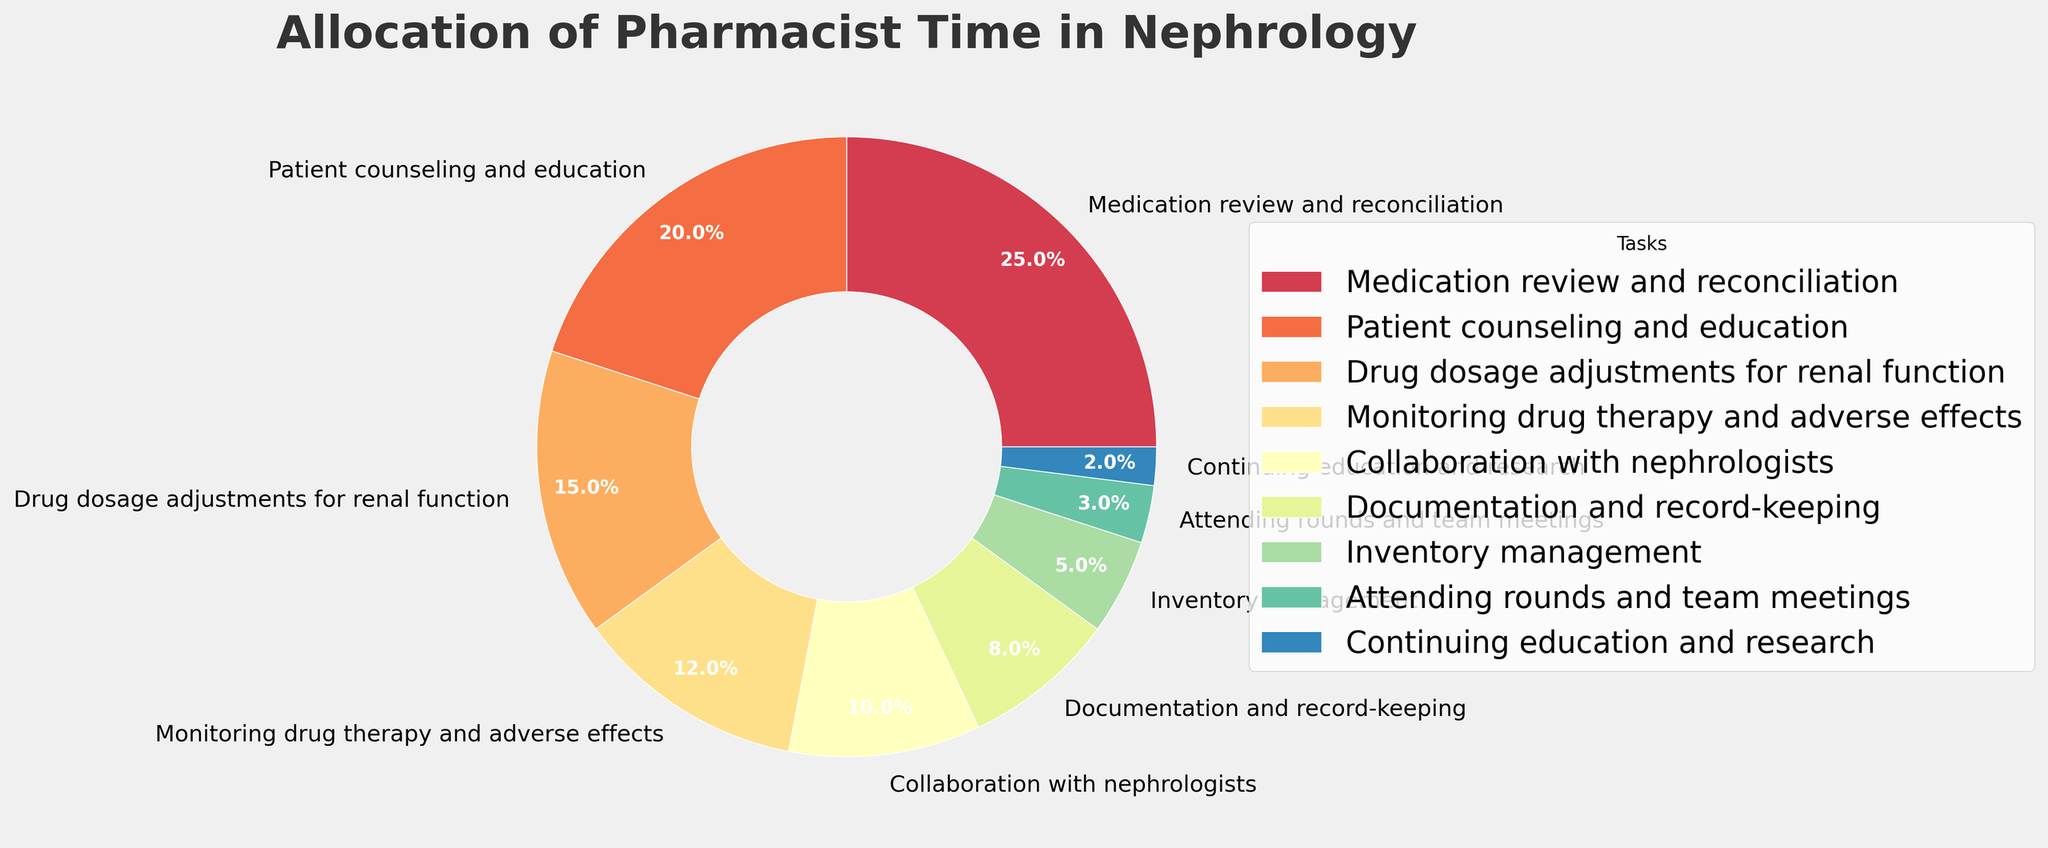What percentage of time is spent on Medication review and reconciliation? The pie chart will have a segment labeled 'Medication review and reconciliation' with its corresponding percentage.
Answer: 25% Which task takes up the least amount of time? Locate the smallest segment in the pie chart and check the label to identify the task.
Answer: Continuing education and research How much more time is allocated to Patient counseling and education compared to Inventory management? Identify the percentages for both 'Patient counseling and education' and 'Inventory management', then subtract the smaller percentage from the larger one: 20% - 5%.
Answer: 15% What is the combined percentage of time spent on Monitoring drug therapy and adverse effects and Documentation and record-keeping? Find the segments labeled 'Monitoring drug therapy and adverse effects' and 'Documentation and record-keeping', then add their percentages together: 12% + 8%.
Answer: 20% Is more time spent on Collaboration with nephrologists or Attending rounds and team meetings? Compare the percentages of 'Collaboration with nephrologists' and 'Attending rounds and team meetings'.
Answer: Collaboration with nephrologists Which two tasks together take up 35% of the pharmacist's time? Review the segments to identify any two tasks whose combined percentages equal 35%. For example, 'Drug dosage adjustments for renal function' (15%) and 'Patient counseling and education' (20%).
Answer: Drug dosage adjustments for renal function and Patient counseling and education What proportion of the pharmacist’s time is spent on Inventory management relative to Medication review and reconciliation? Compare the percentages of 'Inventory management' (5%) and 'Medication review and reconciliation' (25%). Calculate the proportion 5% / 25%.
Answer: 1:5 How does the time spent on Monitoring drug therapy and adverse effects compare to Collaboration with nephrologists? Compare the percentages for 'Monitoring drug therapy and adverse effects' (12%) and 'Collaboration with nephrologists' (10%).
Answer: Monitoring drug therapy and adverse effects is more 